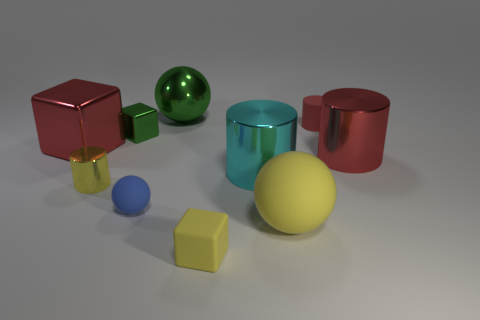Subtract all cubes. How many objects are left? 7 Subtract 0 brown cubes. How many objects are left? 10 Subtract all tiny blue metal balls. Subtract all large green metallic spheres. How many objects are left? 9 Add 8 cyan cylinders. How many cyan cylinders are left? 9 Add 3 purple rubber blocks. How many purple rubber blocks exist? 3 